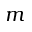<formula> <loc_0><loc_0><loc_500><loc_500>m</formula> 